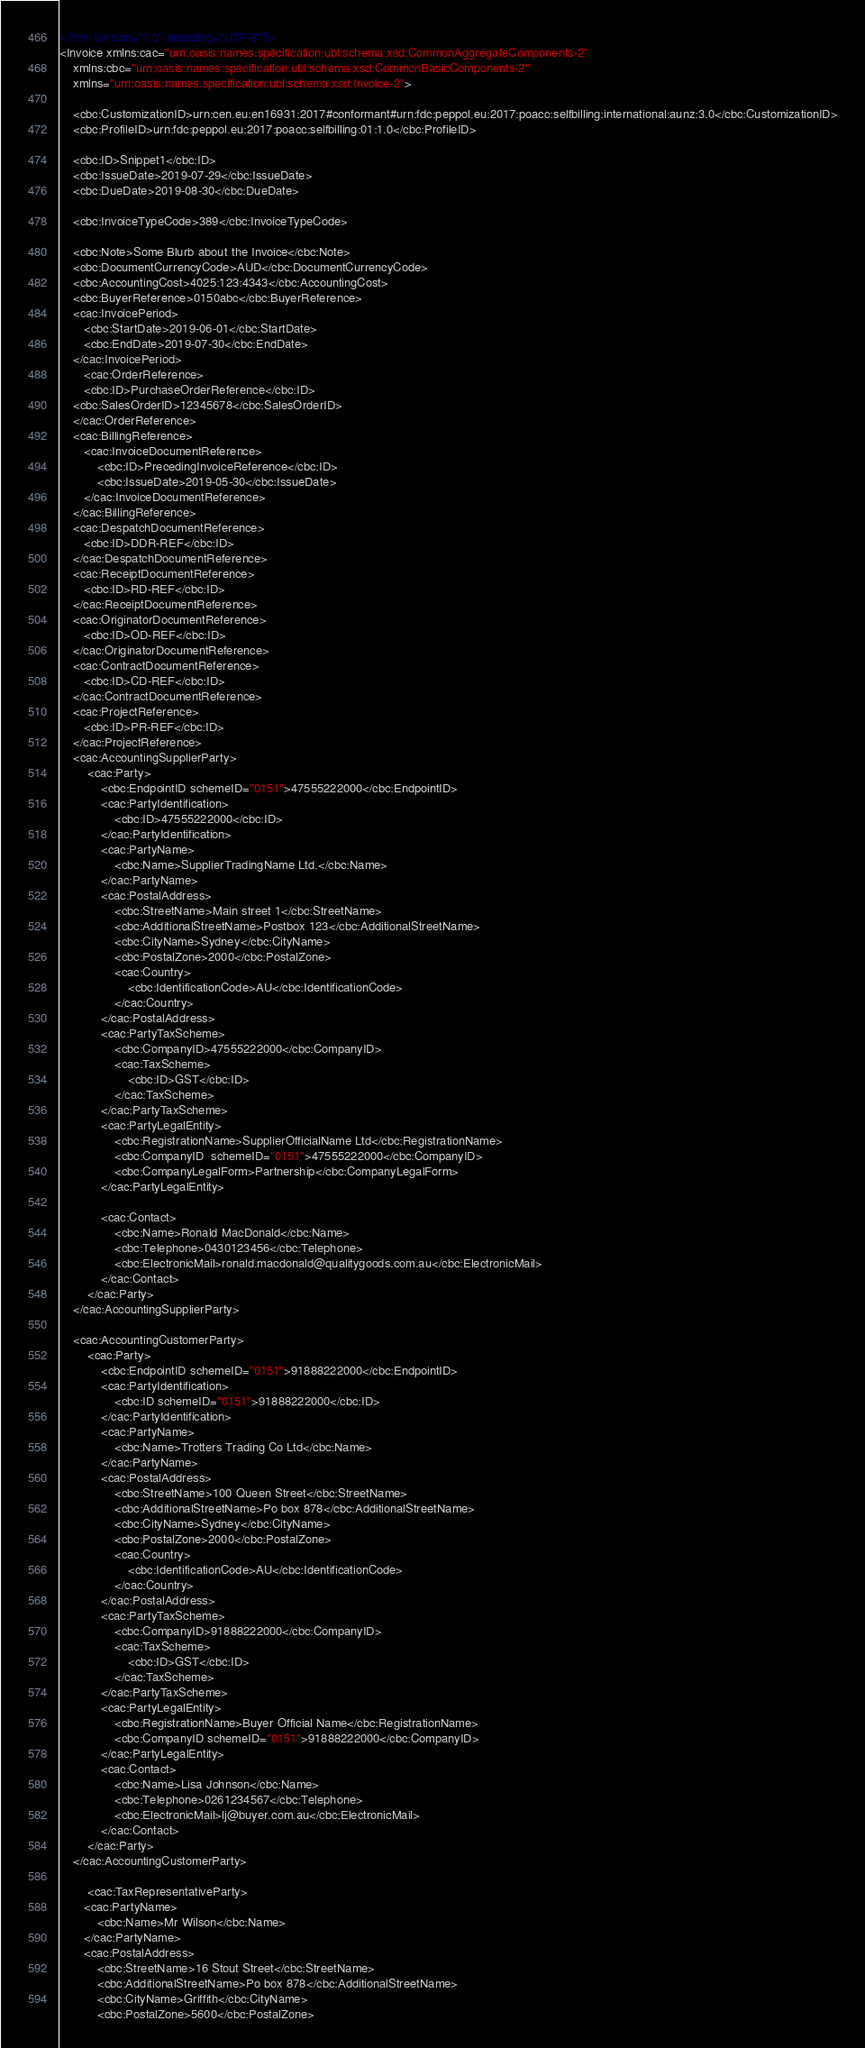<code> <loc_0><loc_0><loc_500><loc_500><_XML_><?xml version="1.0" encoding="UTF-8"?>
<Invoice xmlns:cac="urn:oasis:names:specification:ubl:schema:xsd:CommonAggregateComponents-2"
    xmlns:cbc="urn:oasis:names:specification:ubl:schema:xsd:CommonBasicComponents-2"
    xmlns="urn:oasis:names:specification:ubl:schema:xsd:Invoice-2">

    <cbc:CustomizationID>urn:cen.eu:en16931:2017#conformant#urn:fdc:peppol.eu:2017:poacc:selfbilling:international:aunz:3.0</cbc:CustomizationID>
    <cbc:ProfileID>urn:fdc:peppol.eu:2017:poacc:selfbilling:01:1.0</cbc:ProfileID>

    <cbc:ID>Snippet1</cbc:ID>
    <cbc:IssueDate>2019-07-29</cbc:IssueDate>
    <cbc:DueDate>2019-08-30</cbc:DueDate>

    <cbc:InvoiceTypeCode>389</cbc:InvoiceTypeCode>

    <cbc:Note>Some Blurb about the Invoice</cbc:Note>
    <cbc:DocumentCurrencyCode>AUD</cbc:DocumentCurrencyCode>
    <cbc:AccountingCost>4025:123:4343</cbc:AccountingCost>
    <cbc:BuyerReference>0150abc</cbc:BuyerReference>
    <cac:InvoicePeriod>
       <cbc:StartDate>2019-06-01</cbc:StartDate>
       <cbc:EndDate>2019-07-30</cbc:EndDate>
    </cac:InvoicePeriod>
       <cac:OrderReference>
       <cbc:ID>PurchaseOrderReference</cbc:ID>
    <cbc:SalesOrderID>12345678</cbc:SalesOrderID>
    </cac:OrderReference>
    <cac:BillingReference>
       <cac:InvoiceDocumentReference>
           <cbc:ID>PrecedingInvoiceReference</cbc:ID>
           <cbc:IssueDate>2019-05-30</cbc:IssueDate>
       </cac:InvoiceDocumentReference>
    </cac:BillingReference>
    <cac:DespatchDocumentReference>
       <cbc:ID>DDR-REF</cbc:ID>
    </cac:DespatchDocumentReference>
    <cac:ReceiptDocumentReference>
       <cbc:ID>RD-REF</cbc:ID>
    </cac:ReceiptDocumentReference>
    <cac:OriginatorDocumentReference>
       <cbc:ID>OD-REF</cbc:ID>
    </cac:OriginatorDocumentReference>
    <cac:ContractDocumentReference>
       <cbc:ID>CD-REF</cbc:ID>
    </cac:ContractDocumentReference>
    <cac:ProjectReference>
       <cbc:ID>PR-REF</cbc:ID>
    </cac:ProjectReference>
    <cac:AccountingSupplierParty>
        <cac:Party>
            <cbc:EndpointID schemeID="0151">47555222000</cbc:EndpointID>
            <cac:PartyIdentification>
                <cbc:ID>47555222000</cbc:ID>
            </cac:PartyIdentification>
            <cac:PartyName>
                <cbc:Name>SupplierTradingName Ltd.</cbc:Name>
            </cac:PartyName>
            <cac:PostalAddress>
                <cbc:StreetName>Main street 1</cbc:StreetName>
                <cbc:AdditionalStreetName>Postbox 123</cbc:AdditionalStreetName>
                <cbc:CityName>Sydney</cbc:CityName>
                <cbc:PostalZone>2000</cbc:PostalZone>
                <cac:Country>
                    <cbc:IdentificationCode>AU</cbc:IdentificationCode>
                </cac:Country>
            </cac:PostalAddress>
            <cac:PartyTaxScheme>
                <cbc:CompanyID>47555222000</cbc:CompanyID>
                <cac:TaxScheme>
                    <cbc:ID>GST</cbc:ID>
                </cac:TaxScheme>
            </cac:PartyTaxScheme>
            <cac:PartyLegalEntity>
                <cbc:RegistrationName>SupplierOfficialName Ltd</cbc:RegistrationName>
                <cbc:CompanyID  schemeID="0151">47555222000</cbc:CompanyID>
                <cbc:CompanyLegalForm>Partnership</cbc:CompanyLegalForm>
            </cac:PartyLegalEntity>

            <cac:Contact>
                <cbc:Name>Ronald MacDonald</cbc:Name>
                <cbc:Telephone>0430123456</cbc:Telephone>
                <cbc:ElectronicMail>ronald.macdonald@qualitygoods.com.au</cbc:ElectronicMail>
            </cac:Contact>
        </cac:Party>
    </cac:AccountingSupplierParty>

    <cac:AccountingCustomerParty>
        <cac:Party>
            <cbc:EndpointID schemeID="0151">91888222000</cbc:EndpointID>
            <cac:PartyIdentification>
                <cbc:ID schemeID="0151">91888222000</cbc:ID>
            </cac:PartyIdentification>
            <cac:PartyName>
                <cbc:Name>Trotters Trading Co Ltd</cbc:Name>
            </cac:PartyName>
            <cac:PostalAddress>
                <cbc:StreetName>100 Queen Street</cbc:StreetName>
                <cbc:AdditionalStreetName>Po box 878</cbc:AdditionalStreetName>
                <cbc:CityName>Sydney</cbc:CityName>
                <cbc:PostalZone>2000</cbc:PostalZone>
                <cac:Country>
                    <cbc:IdentificationCode>AU</cbc:IdentificationCode>
                </cac:Country>
            </cac:PostalAddress>
            <cac:PartyTaxScheme>
                <cbc:CompanyID>91888222000</cbc:CompanyID>
                <cac:TaxScheme>
                    <cbc:ID>GST</cbc:ID>
                </cac:TaxScheme>
            </cac:PartyTaxScheme>
            <cac:PartyLegalEntity>
                <cbc:RegistrationName>Buyer Official Name</cbc:RegistrationName>
                <cbc:CompanyID schemeID="0151">91888222000</cbc:CompanyID>
            </cac:PartyLegalEntity>
            <cac:Contact>
                <cbc:Name>Lisa Johnson</cbc:Name>
                <cbc:Telephone>0261234567</cbc:Telephone>
                <cbc:ElectronicMail>lj@buyer.com.au</cbc:ElectronicMail>
            </cac:Contact>
        </cac:Party>
    </cac:AccountingCustomerParty>

        <cac:TaxRepresentativeParty>
       <cac:PartyName>
           <cbc:Name>Mr Wilson</cbc:Name>
       </cac:PartyName>
       <cac:PostalAddress>
           <cbc:StreetName>16 Stout Street</cbc:StreetName>
           <cbc:AdditionalStreetName>Po box 878</cbc:AdditionalStreetName>
           <cbc:CityName>Griffith</cbc:CityName>
           <cbc:PostalZone>5600</cbc:PostalZone></code> 